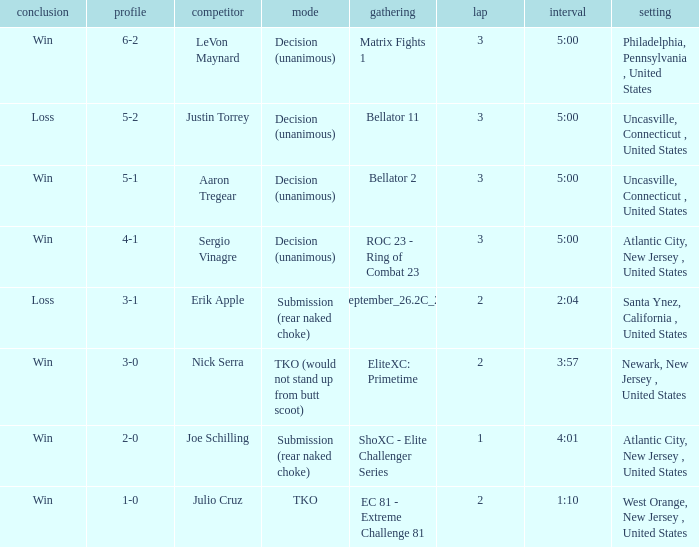Who was the opponent when there was a TKO method? Julio Cruz. 